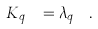<formula> <loc_0><loc_0><loc_500><loc_500>K _ { q _ { s e n } } = \lambda _ { q _ { s e n } } \, .</formula> 